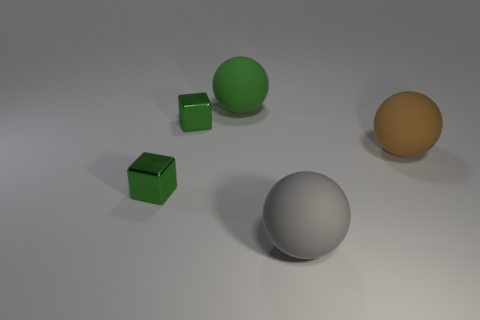Add 1 gray things. How many objects exist? 6 Subtract all spheres. How many objects are left? 2 Subtract 0 purple cylinders. How many objects are left? 5 Subtract all red spheres. Subtract all brown cylinders. How many spheres are left? 3 Subtract all red matte cylinders. Subtract all small green objects. How many objects are left? 3 Add 4 tiny things. How many tiny things are left? 6 Add 4 big green rubber things. How many big green rubber things exist? 5 